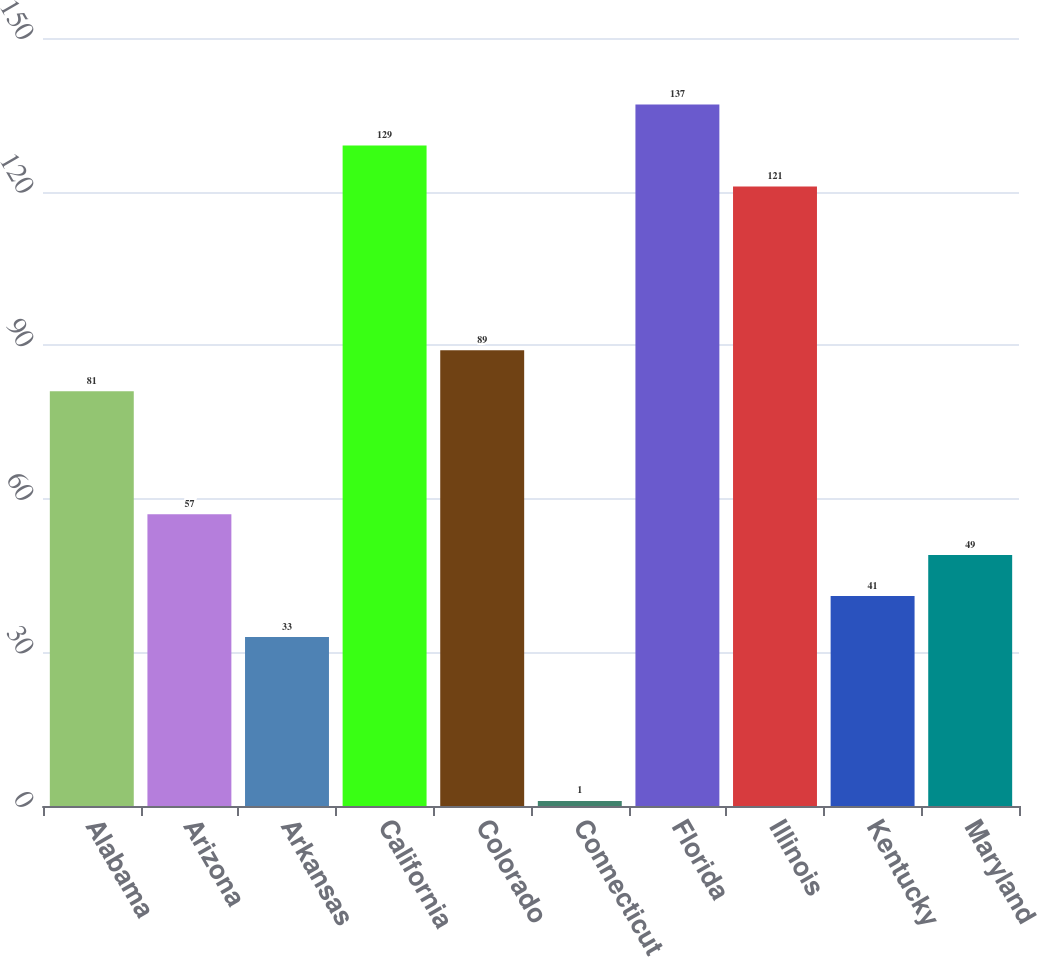<chart> <loc_0><loc_0><loc_500><loc_500><bar_chart><fcel>Alabama<fcel>Arizona<fcel>Arkansas<fcel>California<fcel>Colorado<fcel>Connecticut<fcel>Florida<fcel>Illinois<fcel>Kentucky<fcel>Maryland<nl><fcel>81<fcel>57<fcel>33<fcel>129<fcel>89<fcel>1<fcel>137<fcel>121<fcel>41<fcel>49<nl></chart> 